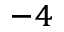<formula> <loc_0><loc_0><loc_500><loc_500>^ { - 4 }</formula> 